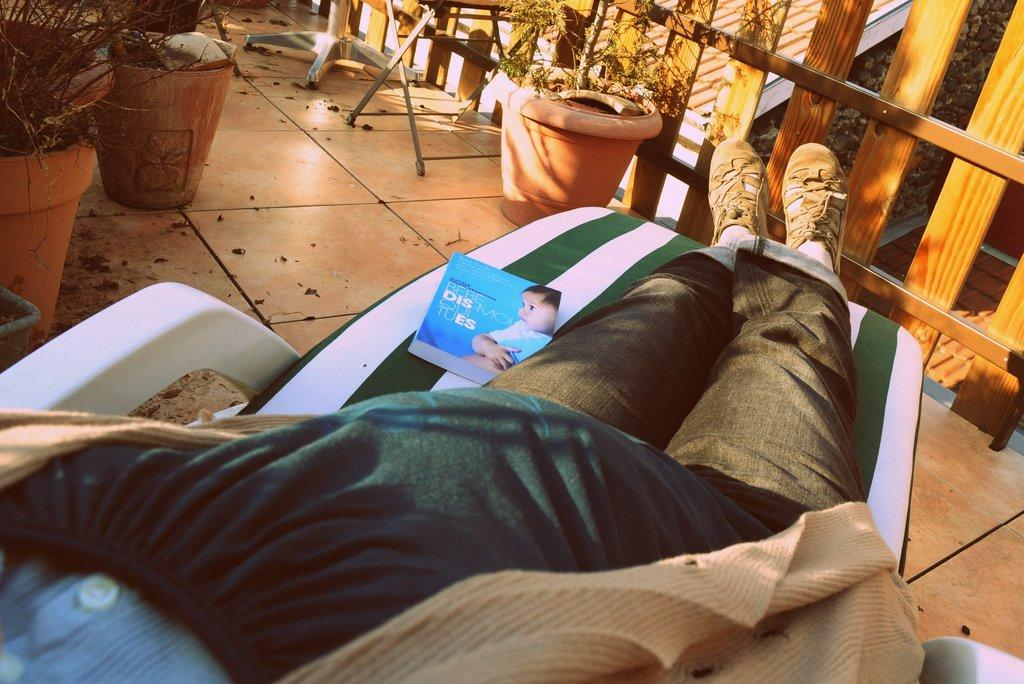What type of living organisms can be seen in the image? Plants are visible in the image. What are the plants contained in? There are pots in the image that contain the plants. What else can be seen in the image besides plants and pots? There are objects, a wooden railing, and a partial part of a person visible in the image. What is the person doing in the image? The person is resting on a chair. What might the person be doing while resting on the chair? There is a magazine on the chair, so the person might be reading it. What is the floor like in the image? The floor is visible in the image. What type of skirt can be seen on the truck in the image? There is no truck present in the image, and therefore no skirt can be seen on it. 